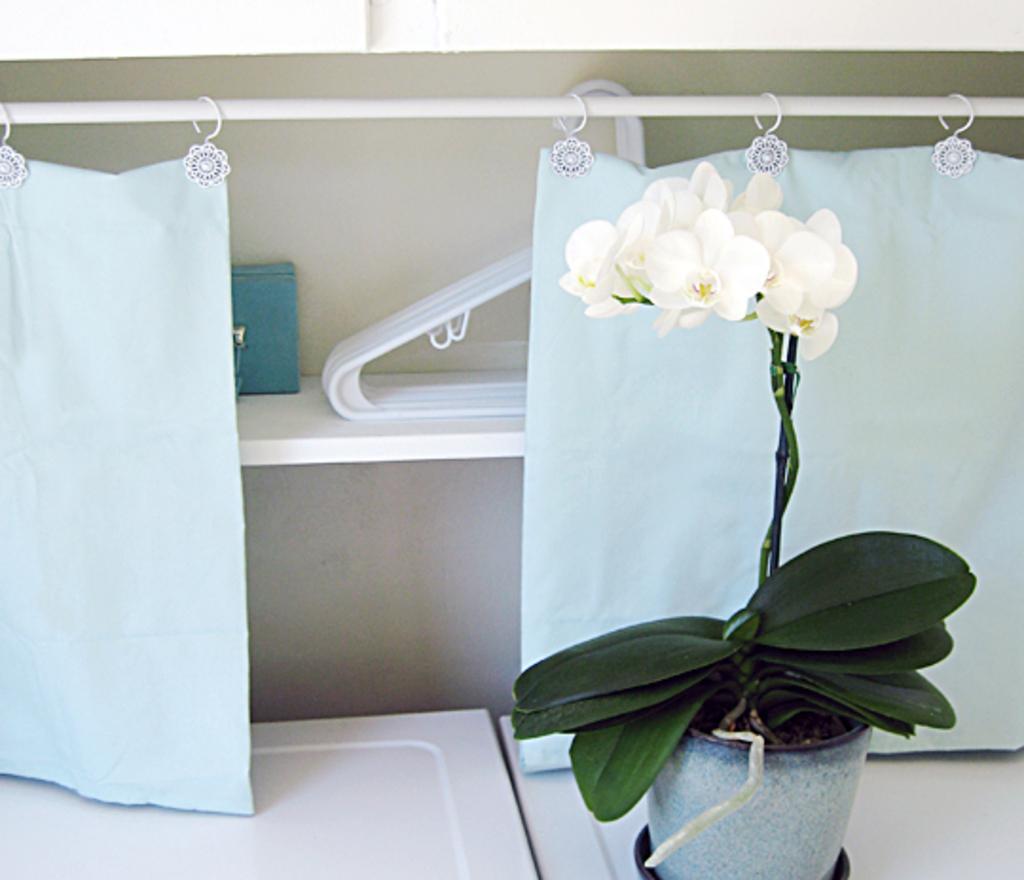Could you give a brief overview of what you see in this image? This image consists of a potted plant. To which there are white flowers. In the background, there are curtains and hangers kept in a shelf. At the bottom, there is a desk in white color. 